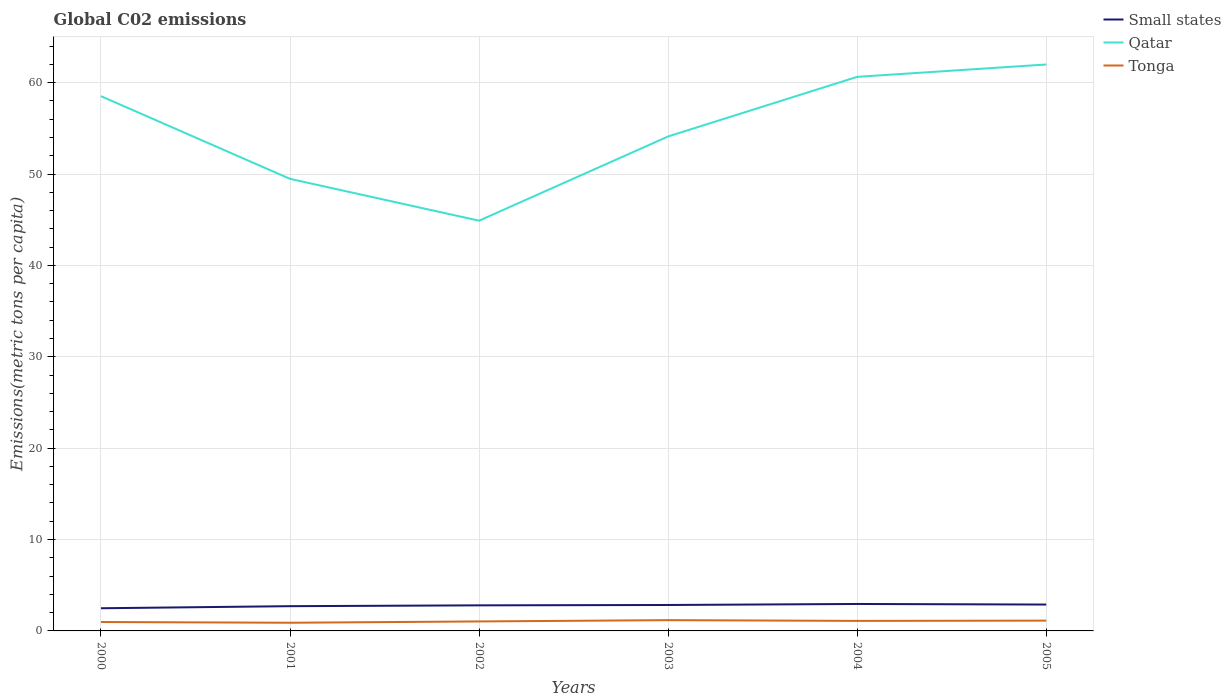How many different coloured lines are there?
Your answer should be very brief. 3. Does the line corresponding to Small states intersect with the line corresponding to Qatar?
Keep it short and to the point. No. Across all years, what is the maximum amount of CO2 emitted in in Small states?
Your answer should be compact. 2.48. In which year was the amount of CO2 emitted in in Tonga maximum?
Offer a terse response. 2001. What is the total amount of CO2 emitted in in Tonga in the graph?
Your answer should be compact. -0.23. What is the difference between the highest and the second highest amount of CO2 emitted in in Tonga?
Give a very brief answer. 0.28. What is the difference between the highest and the lowest amount of CO2 emitted in in Small states?
Offer a very short reply. 4. What is the difference between two consecutive major ticks on the Y-axis?
Offer a terse response. 10. Does the graph contain grids?
Your answer should be compact. Yes. Where does the legend appear in the graph?
Make the answer very short. Top right. How many legend labels are there?
Keep it short and to the point. 3. How are the legend labels stacked?
Make the answer very short. Vertical. What is the title of the graph?
Keep it short and to the point. Global C02 emissions. Does "St. Vincent and the Grenadines" appear as one of the legend labels in the graph?
Make the answer very short. No. What is the label or title of the Y-axis?
Provide a succinct answer. Emissions(metric tons per capita). What is the Emissions(metric tons per capita) of Small states in 2000?
Offer a terse response. 2.48. What is the Emissions(metric tons per capita) in Qatar in 2000?
Your answer should be compact. 58.52. What is the Emissions(metric tons per capita) of Tonga in 2000?
Keep it short and to the point. 0.97. What is the Emissions(metric tons per capita) of Small states in 2001?
Your answer should be compact. 2.71. What is the Emissions(metric tons per capita) in Qatar in 2001?
Offer a terse response. 49.47. What is the Emissions(metric tons per capita) in Tonga in 2001?
Ensure brevity in your answer.  0.89. What is the Emissions(metric tons per capita) in Small states in 2002?
Your answer should be very brief. 2.8. What is the Emissions(metric tons per capita) in Qatar in 2002?
Offer a terse response. 44.9. What is the Emissions(metric tons per capita) in Tonga in 2002?
Offer a terse response. 1.04. What is the Emissions(metric tons per capita) of Small states in 2003?
Your answer should be compact. 2.84. What is the Emissions(metric tons per capita) in Qatar in 2003?
Make the answer very short. 54.11. What is the Emissions(metric tons per capita) of Tonga in 2003?
Your answer should be very brief. 1.18. What is the Emissions(metric tons per capita) of Small states in 2004?
Make the answer very short. 2.95. What is the Emissions(metric tons per capita) in Qatar in 2004?
Keep it short and to the point. 60.64. What is the Emissions(metric tons per capita) in Tonga in 2004?
Give a very brief answer. 1.1. What is the Emissions(metric tons per capita) in Small states in 2005?
Ensure brevity in your answer.  2.89. What is the Emissions(metric tons per capita) in Qatar in 2005?
Your response must be concise. 61.99. What is the Emissions(metric tons per capita) of Tonga in 2005?
Your response must be concise. 1.13. Across all years, what is the maximum Emissions(metric tons per capita) in Small states?
Provide a short and direct response. 2.95. Across all years, what is the maximum Emissions(metric tons per capita) of Qatar?
Your response must be concise. 61.99. Across all years, what is the maximum Emissions(metric tons per capita) of Tonga?
Your response must be concise. 1.18. Across all years, what is the minimum Emissions(metric tons per capita) of Small states?
Make the answer very short. 2.48. Across all years, what is the minimum Emissions(metric tons per capita) in Qatar?
Offer a very short reply. 44.9. Across all years, what is the minimum Emissions(metric tons per capita) of Tonga?
Offer a very short reply. 0.89. What is the total Emissions(metric tons per capita) in Small states in the graph?
Offer a terse response. 16.66. What is the total Emissions(metric tons per capita) in Qatar in the graph?
Your answer should be very brief. 329.63. What is the total Emissions(metric tons per capita) of Tonga in the graph?
Make the answer very short. 6.31. What is the difference between the Emissions(metric tons per capita) of Small states in 2000 and that in 2001?
Provide a succinct answer. -0.23. What is the difference between the Emissions(metric tons per capita) of Qatar in 2000 and that in 2001?
Provide a succinct answer. 9.05. What is the difference between the Emissions(metric tons per capita) in Tonga in 2000 and that in 2001?
Give a very brief answer. 0.08. What is the difference between the Emissions(metric tons per capita) of Small states in 2000 and that in 2002?
Make the answer very short. -0.32. What is the difference between the Emissions(metric tons per capita) of Qatar in 2000 and that in 2002?
Provide a short and direct response. 13.63. What is the difference between the Emissions(metric tons per capita) of Tonga in 2000 and that in 2002?
Keep it short and to the point. -0.06. What is the difference between the Emissions(metric tons per capita) in Small states in 2000 and that in 2003?
Give a very brief answer. -0.36. What is the difference between the Emissions(metric tons per capita) in Qatar in 2000 and that in 2003?
Ensure brevity in your answer.  4.41. What is the difference between the Emissions(metric tons per capita) of Tonga in 2000 and that in 2003?
Provide a succinct answer. -0.2. What is the difference between the Emissions(metric tons per capita) of Small states in 2000 and that in 2004?
Offer a terse response. -0.47. What is the difference between the Emissions(metric tons per capita) of Qatar in 2000 and that in 2004?
Provide a short and direct response. -2.12. What is the difference between the Emissions(metric tons per capita) of Tonga in 2000 and that in 2004?
Give a very brief answer. -0.12. What is the difference between the Emissions(metric tons per capita) of Small states in 2000 and that in 2005?
Give a very brief answer. -0.41. What is the difference between the Emissions(metric tons per capita) of Qatar in 2000 and that in 2005?
Offer a terse response. -3.47. What is the difference between the Emissions(metric tons per capita) of Tonga in 2000 and that in 2005?
Keep it short and to the point. -0.15. What is the difference between the Emissions(metric tons per capita) of Small states in 2001 and that in 2002?
Give a very brief answer. -0.09. What is the difference between the Emissions(metric tons per capita) in Qatar in 2001 and that in 2002?
Make the answer very short. 4.58. What is the difference between the Emissions(metric tons per capita) of Tonga in 2001 and that in 2002?
Make the answer very short. -0.14. What is the difference between the Emissions(metric tons per capita) of Small states in 2001 and that in 2003?
Provide a short and direct response. -0.13. What is the difference between the Emissions(metric tons per capita) of Qatar in 2001 and that in 2003?
Ensure brevity in your answer.  -4.64. What is the difference between the Emissions(metric tons per capita) in Tonga in 2001 and that in 2003?
Offer a terse response. -0.28. What is the difference between the Emissions(metric tons per capita) of Small states in 2001 and that in 2004?
Your answer should be compact. -0.24. What is the difference between the Emissions(metric tons per capita) of Qatar in 2001 and that in 2004?
Your answer should be compact. -11.16. What is the difference between the Emissions(metric tons per capita) in Tonga in 2001 and that in 2004?
Keep it short and to the point. -0.2. What is the difference between the Emissions(metric tons per capita) of Small states in 2001 and that in 2005?
Keep it short and to the point. -0.18. What is the difference between the Emissions(metric tons per capita) in Qatar in 2001 and that in 2005?
Provide a succinct answer. -12.52. What is the difference between the Emissions(metric tons per capita) of Tonga in 2001 and that in 2005?
Make the answer very short. -0.23. What is the difference between the Emissions(metric tons per capita) in Small states in 2002 and that in 2003?
Keep it short and to the point. -0.04. What is the difference between the Emissions(metric tons per capita) of Qatar in 2002 and that in 2003?
Provide a succinct answer. -9.22. What is the difference between the Emissions(metric tons per capita) of Tonga in 2002 and that in 2003?
Give a very brief answer. -0.14. What is the difference between the Emissions(metric tons per capita) in Small states in 2002 and that in 2004?
Your response must be concise. -0.15. What is the difference between the Emissions(metric tons per capita) in Qatar in 2002 and that in 2004?
Make the answer very short. -15.74. What is the difference between the Emissions(metric tons per capita) of Tonga in 2002 and that in 2004?
Offer a terse response. -0.06. What is the difference between the Emissions(metric tons per capita) in Small states in 2002 and that in 2005?
Make the answer very short. -0.09. What is the difference between the Emissions(metric tons per capita) in Qatar in 2002 and that in 2005?
Provide a succinct answer. -17.09. What is the difference between the Emissions(metric tons per capita) in Tonga in 2002 and that in 2005?
Offer a very short reply. -0.09. What is the difference between the Emissions(metric tons per capita) in Small states in 2003 and that in 2004?
Your answer should be compact. -0.11. What is the difference between the Emissions(metric tons per capita) in Qatar in 2003 and that in 2004?
Keep it short and to the point. -6.52. What is the difference between the Emissions(metric tons per capita) in Tonga in 2003 and that in 2004?
Give a very brief answer. 0.08. What is the difference between the Emissions(metric tons per capita) of Small states in 2003 and that in 2005?
Keep it short and to the point. -0.05. What is the difference between the Emissions(metric tons per capita) of Qatar in 2003 and that in 2005?
Your response must be concise. -7.88. What is the difference between the Emissions(metric tons per capita) of Tonga in 2003 and that in 2005?
Ensure brevity in your answer.  0.05. What is the difference between the Emissions(metric tons per capita) in Small states in 2004 and that in 2005?
Provide a short and direct response. 0.06. What is the difference between the Emissions(metric tons per capita) of Qatar in 2004 and that in 2005?
Your answer should be very brief. -1.35. What is the difference between the Emissions(metric tons per capita) of Tonga in 2004 and that in 2005?
Keep it short and to the point. -0.03. What is the difference between the Emissions(metric tons per capita) of Small states in 2000 and the Emissions(metric tons per capita) of Qatar in 2001?
Provide a succinct answer. -46.99. What is the difference between the Emissions(metric tons per capita) of Small states in 2000 and the Emissions(metric tons per capita) of Tonga in 2001?
Make the answer very short. 1.59. What is the difference between the Emissions(metric tons per capita) of Qatar in 2000 and the Emissions(metric tons per capita) of Tonga in 2001?
Ensure brevity in your answer.  57.63. What is the difference between the Emissions(metric tons per capita) in Small states in 2000 and the Emissions(metric tons per capita) in Qatar in 2002?
Your answer should be very brief. -42.42. What is the difference between the Emissions(metric tons per capita) of Small states in 2000 and the Emissions(metric tons per capita) of Tonga in 2002?
Your response must be concise. 1.44. What is the difference between the Emissions(metric tons per capita) in Qatar in 2000 and the Emissions(metric tons per capita) in Tonga in 2002?
Offer a very short reply. 57.49. What is the difference between the Emissions(metric tons per capita) of Small states in 2000 and the Emissions(metric tons per capita) of Qatar in 2003?
Provide a short and direct response. -51.63. What is the difference between the Emissions(metric tons per capita) of Small states in 2000 and the Emissions(metric tons per capita) of Tonga in 2003?
Offer a very short reply. 1.3. What is the difference between the Emissions(metric tons per capita) of Qatar in 2000 and the Emissions(metric tons per capita) of Tonga in 2003?
Offer a terse response. 57.34. What is the difference between the Emissions(metric tons per capita) of Small states in 2000 and the Emissions(metric tons per capita) of Qatar in 2004?
Offer a very short reply. -58.16. What is the difference between the Emissions(metric tons per capita) in Small states in 2000 and the Emissions(metric tons per capita) in Tonga in 2004?
Your answer should be compact. 1.38. What is the difference between the Emissions(metric tons per capita) in Qatar in 2000 and the Emissions(metric tons per capita) in Tonga in 2004?
Give a very brief answer. 57.42. What is the difference between the Emissions(metric tons per capita) of Small states in 2000 and the Emissions(metric tons per capita) of Qatar in 2005?
Offer a very short reply. -59.51. What is the difference between the Emissions(metric tons per capita) in Small states in 2000 and the Emissions(metric tons per capita) in Tonga in 2005?
Your response must be concise. 1.35. What is the difference between the Emissions(metric tons per capita) of Qatar in 2000 and the Emissions(metric tons per capita) of Tonga in 2005?
Your answer should be very brief. 57.4. What is the difference between the Emissions(metric tons per capita) in Small states in 2001 and the Emissions(metric tons per capita) in Qatar in 2002?
Provide a short and direct response. -42.19. What is the difference between the Emissions(metric tons per capita) of Small states in 2001 and the Emissions(metric tons per capita) of Tonga in 2002?
Provide a succinct answer. 1.67. What is the difference between the Emissions(metric tons per capita) of Qatar in 2001 and the Emissions(metric tons per capita) of Tonga in 2002?
Keep it short and to the point. 48.44. What is the difference between the Emissions(metric tons per capita) in Small states in 2001 and the Emissions(metric tons per capita) in Qatar in 2003?
Ensure brevity in your answer.  -51.41. What is the difference between the Emissions(metric tons per capita) in Small states in 2001 and the Emissions(metric tons per capita) in Tonga in 2003?
Offer a terse response. 1.53. What is the difference between the Emissions(metric tons per capita) of Qatar in 2001 and the Emissions(metric tons per capita) of Tonga in 2003?
Provide a succinct answer. 48.3. What is the difference between the Emissions(metric tons per capita) of Small states in 2001 and the Emissions(metric tons per capita) of Qatar in 2004?
Provide a succinct answer. -57.93. What is the difference between the Emissions(metric tons per capita) in Small states in 2001 and the Emissions(metric tons per capita) in Tonga in 2004?
Your response must be concise. 1.61. What is the difference between the Emissions(metric tons per capita) in Qatar in 2001 and the Emissions(metric tons per capita) in Tonga in 2004?
Offer a terse response. 48.38. What is the difference between the Emissions(metric tons per capita) of Small states in 2001 and the Emissions(metric tons per capita) of Qatar in 2005?
Ensure brevity in your answer.  -59.28. What is the difference between the Emissions(metric tons per capita) in Small states in 2001 and the Emissions(metric tons per capita) in Tonga in 2005?
Offer a very short reply. 1.58. What is the difference between the Emissions(metric tons per capita) in Qatar in 2001 and the Emissions(metric tons per capita) in Tonga in 2005?
Your answer should be compact. 48.35. What is the difference between the Emissions(metric tons per capita) of Small states in 2002 and the Emissions(metric tons per capita) of Qatar in 2003?
Provide a short and direct response. -51.31. What is the difference between the Emissions(metric tons per capita) of Small states in 2002 and the Emissions(metric tons per capita) of Tonga in 2003?
Your answer should be compact. 1.62. What is the difference between the Emissions(metric tons per capita) in Qatar in 2002 and the Emissions(metric tons per capita) in Tonga in 2003?
Give a very brief answer. 43.72. What is the difference between the Emissions(metric tons per capita) in Small states in 2002 and the Emissions(metric tons per capita) in Qatar in 2004?
Your response must be concise. -57.84. What is the difference between the Emissions(metric tons per capita) in Small states in 2002 and the Emissions(metric tons per capita) in Tonga in 2004?
Your answer should be very brief. 1.7. What is the difference between the Emissions(metric tons per capita) of Qatar in 2002 and the Emissions(metric tons per capita) of Tonga in 2004?
Provide a succinct answer. 43.8. What is the difference between the Emissions(metric tons per capita) in Small states in 2002 and the Emissions(metric tons per capita) in Qatar in 2005?
Provide a succinct answer. -59.19. What is the difference between the Emissions(metric tons per capita) in Small states in 2002 and the Emissions(metric tons per capita) in Tonga in 2005?
Ensure brevity in your answer.  1.67. What is the difference between the Emissions(metric tons per capita) of Qatar in 2002 and the Emissions(metric tons per capita) of Tonga in 2005?
Your response must be concise. 43.77. What is the difference between the Emissions(metric tons per capita) in Small states in 2003 and the Emissions(metric tons per capita) in Qatar in 2004?
Your answer should be very brief. -57.8. What is the difference between the Emissions(metric tons per capita) of Small states in 2003 and the Emissions(metric tons per capita) of Tonga in 2004?
Your answer should be very brief. 1.74. What is the difference between the Emissions(metric tons per capita) in Qatar in 2003 and the Emissions(metric tons per capita) in Tonga in 2004?
Provide a succinct answer. 53.02. What is the difference between the Emissions(metric tons per capita) of Small states in 2003 and the Emissions(metric tons per capita) of Qatar in 2005?
Your answer should be very brief. -59.15. What is the difference between the Emissions(metric tons per capita) in Small states in 2003 and the Emissions(metric tons per capita) in Tonga in 2005?
Give a very brief answer. 1.71. What is the difference between the Emissions(metric tons per capita) of Qatar in 2003 and the Emissions(metric tons per capita) of Tonga in 2005?
Make the answer very short. 52.99. What is the difference between the Emissions(metric tons per capita) in Small states in 2004 and the Emissions(metric tons per capita) in Qatar in 2005?
Make the answer very short. -59.04. What is the difference between the Emissions(metric tons per capita) in Small states in 2004 and the Emissions(metric tons per capita) in Tonga in 2005?
Your response must be concise. 1.82. What is the difference between the Emissions(metric tons per capita) in Qatar in 2004 and the Emissions(metric tons per capita) in Tonga in 2005?
Keep it short and to the point. 59.51. What is the average Emissions(metric tons per capita) in Small states per year?
Give a very brief answer. 2.78. What is the average Emissions(metric tons per capita) in Qatar per year?
Provide a succinct answer. 54.94. What is the average Emissions(metric tons per capita) in Tonga per year?
Your answer should be very brief. 1.05. In the year 2000, what is the difference between the Emissions(metric tons per capita) in Small states and Emissions(metric tons per capita) in Qatar?
Your answer should be very brief. -56.04. In the year 2000, what is the difference between the Emissions(metric tons per capita) in Small states and Emissions(metric tons per capita) in Tonga?
Your response must be concise. 1.51. In the year 2000, what is the difference between the Emissions(metric tons per capita) of Qatar and Emissions(metric tons per capita) of Tonga?
Provide a short and direct response. 57.55. In the year 2001, what is the difference between the Emissions(metric tons per capita) of Small states and Emissions(metric tons per capita) of Qatar?
Provide a succinct answer. -46.77. In the year 2001, what is the difference between the Emissions(metric tons per capita) of Small states and Emissions(metric tons per capita) of Tonga?
Offer a very short reply. 1.81. In the year 2001, what is the difference between the Emissions(metric tons per capita) of Qatar and Emissions(metric tons per capita) of Tonga?
Your answer should be compact. 48.58. In the year 2002, what is the difference between the Emissions(metric tons per capita) in Small states and Emissions(metric tons per capita) in Qatar?
Your answer should be very brief. -42.1. In the year 2002, what is the difference between the Emissions(metric tons per capita) in Small states and Emissions(metric tons per capita) in Tonga?
Keep it short and to the point. 1.76. In the year 2002, what is the difference between the Emissions(metric tons per capita) of Qatar and Emissions(metric tons per capita) of Tonga?
Provide a short and direct response. 43.86. In the year 2003, what is the difference between the Emissions(metric tons per capita) of Small states and Emissions(metric tons per capita) of Qatar?
Offer a terse response. -51.27. In the year 2003, what is the difference between the Emissions(metric tons per capita) in Small states and Emissions(metric tons per capita) in Tonga?
Your answer should be compact. 1.66. In the year 2003, what is the difference between the Emissions(metric tons per capita) of Qatar and Emissions(metric tons per capita) of Tonga?
Your response must be concise. 52.94. In the year 2004, what is the difference between the Emissions(metric tons per capita) of Small states and Emissions(metric tons per capita) of Qatar?
Offer a very short reply. -57.69. In the year 2004, what is the difference between the Emissions(metric tons per capita) in Small states and Emissions(metric tons per capita) in Tonga?
Your answer should be very brief. 1.85. In the year 2004, what is the difference between the Emissions(metric tons per capita) of Qatar and Emissions(metric tons per capita) of Tonga?
Your answer should be very brief. 59.54. In the year 2005, what is the difference between the Emissions(metric tons per capita) of Small states and Emissions(metric tons per capita) of Qatar?
Your answer should be very brief. -59.1. In the year 2005, what is the difference between the Emissions(metric tons per capita) of Small states and Emissions(metric tons per capita) of Tonga?
Make the answer very short. 1.76. In the year 2005, what is the difference between the Emissions(metric tons per capita) in Qatar and Emissions(metric tons per capita) in Tonga?
Provide a succinct answer. 60.86. What is the ratio of the Emissions(metric tons per capita) in Small states in 2000 to that in 2001?
Make the answer very short. 0.92. What is the ratio of the Emissions(metric tons per capita) of Qatar in 2000 to that in 2001?
Make the answer very short. 1.18. What is the ratio of the Emissions(metric tons per capita) of Tonga in 2000 to that in 2001?
Provide a short and direct response. 1.09. What is the ratio of the Emissions(metric tons per capita) in Small states in 2000 to that in 2002?
Your answer should be compact. 0.89. What is the ratio of the Emissions(metric tons per capita) in Qatar in 2000 to that in 2002?
Your answer should be very brief. 1.3. What is the ratio of the Emissions(metric tons per capita) in Tonga in 2000 to that in 2002?
Your answer should be compact. 0.94. What is the ratio of the Emissions(metric tons per capita) in Small states in 2000 to that in 2003?
Ensure brevity in your answer.  0.87. What is the ratio of the Emissions(metric tons per capita) in Qatar in 2000 to that in 2003?
Offer a terse response. 1.08. What is the ratio of the Emissions(metric tons per capita) of Tonga in 2000 to that in 2003?
Your answer should be very brief. 0.83. What is the ratio of the Emissions(metric tons per capita) in Small states in 2000 to that in 2004?
Your answer should be very brief. 0.84. What is the ratio of the Emissions(metric tons per capita) of Qatar in 2000 to that in 2004?
Provide a succinct answer. 0.97. What is the ratio of the Emissions(metric tons per capita) in Tonga in 2000 to that in 2004?
Make the answer very short. 0.89. What is the ratio of the Emissions(metric tons per capita) of Small states in 2000 to that in 2005?
Offer a very short reply. 0.86. What is the ratio of the Emissions(metric tons per capita) of Qatar in 2000 to that in 2005?
Provide a short and direct response. 0.94. What is the ratio of the Emissions(metric tons per capita) in Tonga in 2000 to that in 2005?
Your answer should be compact. 0.86. What is the ratio of the Emissions(metric tons per capita) of Small states in 2001 to that in 2002?
Offer a very short reply. 0.97. What is the ratio of the Emissions(metric tons per capita) of Qatar in 2001 to that in 2002?
Keep it short and to the point. 1.1. What is the ratio of the Emissions(metric tons per capita) in Tonga in 2001 to that in 2002?
Offer a very short reply. 0.86. What is the ratio of the Emissions(metric tons per capita) of Small states in 2001 to that in 2003?
Your response must be concise. 0.95. What is the ratio of the Emissions(metric tons per capita) of Qatar in 2001 to that in 2003?
Give a very brief answer. 0.91. What is the ratio of the Emissions(metric tons per capita) in Tonga in 2001 to that in 2003?
Your answer should be compact. 0.76. What is the ratio of the Emissions(metric tons per capita) of Small states in 2001 to that in 2004?
Ensure brevity in your answer.  0.92. What is the ratio of the Emissions(metric tons per capita) of Qatar in 2001 to that in 2004?
Your response must be concise. 0.82. What is the ratio of the Emissions(metric tons per capita) in Tonga in 2001 to that in 2004?
Provide a short and direct response. 0.81. What is the ratio of the Emissions(metric tons per capita) of Small states in 2001 to that in 2005?
Provide a succinct answer. 0.94. What is the ratio of the Emissions(metric tons per capita) of Qatar in 2001 to that in 2005?
Keep it short and to the point. 0.8. What is the ratio of the Emissions(metric tons per capita) in Tonga in 2001 to that in 2005?
Your answer should be very brief. 0.79. What is the ratio of the Emissions(metric tons per capita) in Small states in 2002 to that in 2003?
Your answer should be very brief. 0.99. What is the ratio of the Emissions(metric tons per capita) of Qatar in 2002 to that in 2003?
Give a very brief answer. 0.83. What is the ratio of the Emissions(metric tons per capita) of Tonga in 2002 to that in 2003?
Offer a terse response. 0.88. What is the ratio of the Emissions(metric tons per capita) of Small states in 2002 to that in 2004?
Give a very brief answer. 0.95. What is the ratio of the Emissions(metric tons per capita) of Qatar in 2002 to that in 2004?
Make the answer very short. 0.74. What is the ratio of the Emissions(metric tons per capita) in Tonga in 2002 to that in 2004?
Give a very brief answer. 0.94. What is the ratio of the Emissions(metric tons per capita) in Small states in 2002 to that in 2005?
Your answer should be compact. 0.97. What is the ratio of the Emissions(metric tons per capita) in Qatar in 2002 to that in 2005?
Your answer should be compact. 0.72. What is the ratio of the Emissions(metric tons per capita) of Tonga in 2002 to that in 2005?
Provide a succinct answer. 0.92. What is the ratio of the Emissions(metric tons per capita) in Small states in 2003 to that in 2004?
Provide a short and direct response. 0.96. What is the ratio of the Emissions(metric tons per capita) of Qatar in 2003 to that in 2004?
Your answer should be very brief. 0.89. What is the ratio of the Emissions(metric tons per capita) in Tonga in 2003 to that in 2004?
Your response must be concise. 1.07. What is the ratio of the Emissions(metric tons per capita) of Small states in 2003 to that in 2005?
Provide a short and direct response. 0.98. What is the ratio of the Emissions(metric tons per capita) in Qatar in 2003 to that in 2005?
Your answer should be very brief. 0.87. What is the ratio of the Emissions(metric tons per capita) in Tonga in 2003 to that in 2005?
Your answer should be compact. 1.05. What is the ratio of the Emissions(metric tons per capita) of Small states in 2004 to that in 2005?
Offer a terse response. 1.02. What is the ratio of the Emissions(metric tons per capita) in Qatar in 2004 to that in 2005?
Offer a terse response. 0.98. What is the ratio of the Emissions(metric tons per capita) in Tonga in 2004 to that in 2005?
Offer a terse response. 0.97. What is the difference between the highest and the second highest Emissions(metric tons per capita) of Small states?
Your response must be concise. 0.06. What is the difference between the highest and the second highest Emissions(metric tons per capita) in Qatar?
Ensure brevity in your answer.  1.35. What is the difference between the highest and the second highest Emissions(metric tons per capita) in Tonga?
Your response must be concise. 0.05. What is the difference between the highest and the lowest Emissions(metric tons per capita) of Small states?
Your answer should be very brief. 0.47. What is the difference between the highest and the lowest Emissions(metric tons per capita) of Qatar?
Your answer should be very brief. 17.09. What is the difference between the highest and the lowest Emissions(metric tons per capita) in Tonga?
Provide a succinct answer. 0.28. 